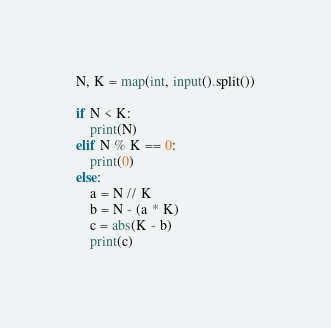<code> <loc_0><loc_0><loc_500><loc_500><_Python_>N, K = map(int, input().split())

if N < K:
    print(N)
elif N % K == 0:
    print(0)
else:
    a = N // K
    b = N - (a * K)
    c = abs(K - b)
    print(c)</code> 